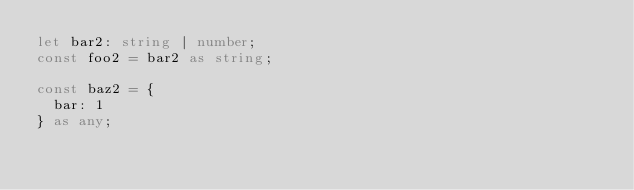Convert code to text. <code><loc_0><loc_0><loc_500><loc_500><_TypeScript_>let bar2: string | number;
const foo2 = bar2 as string;

const baz2 = {
  bar: 1
} as any;
</code> 